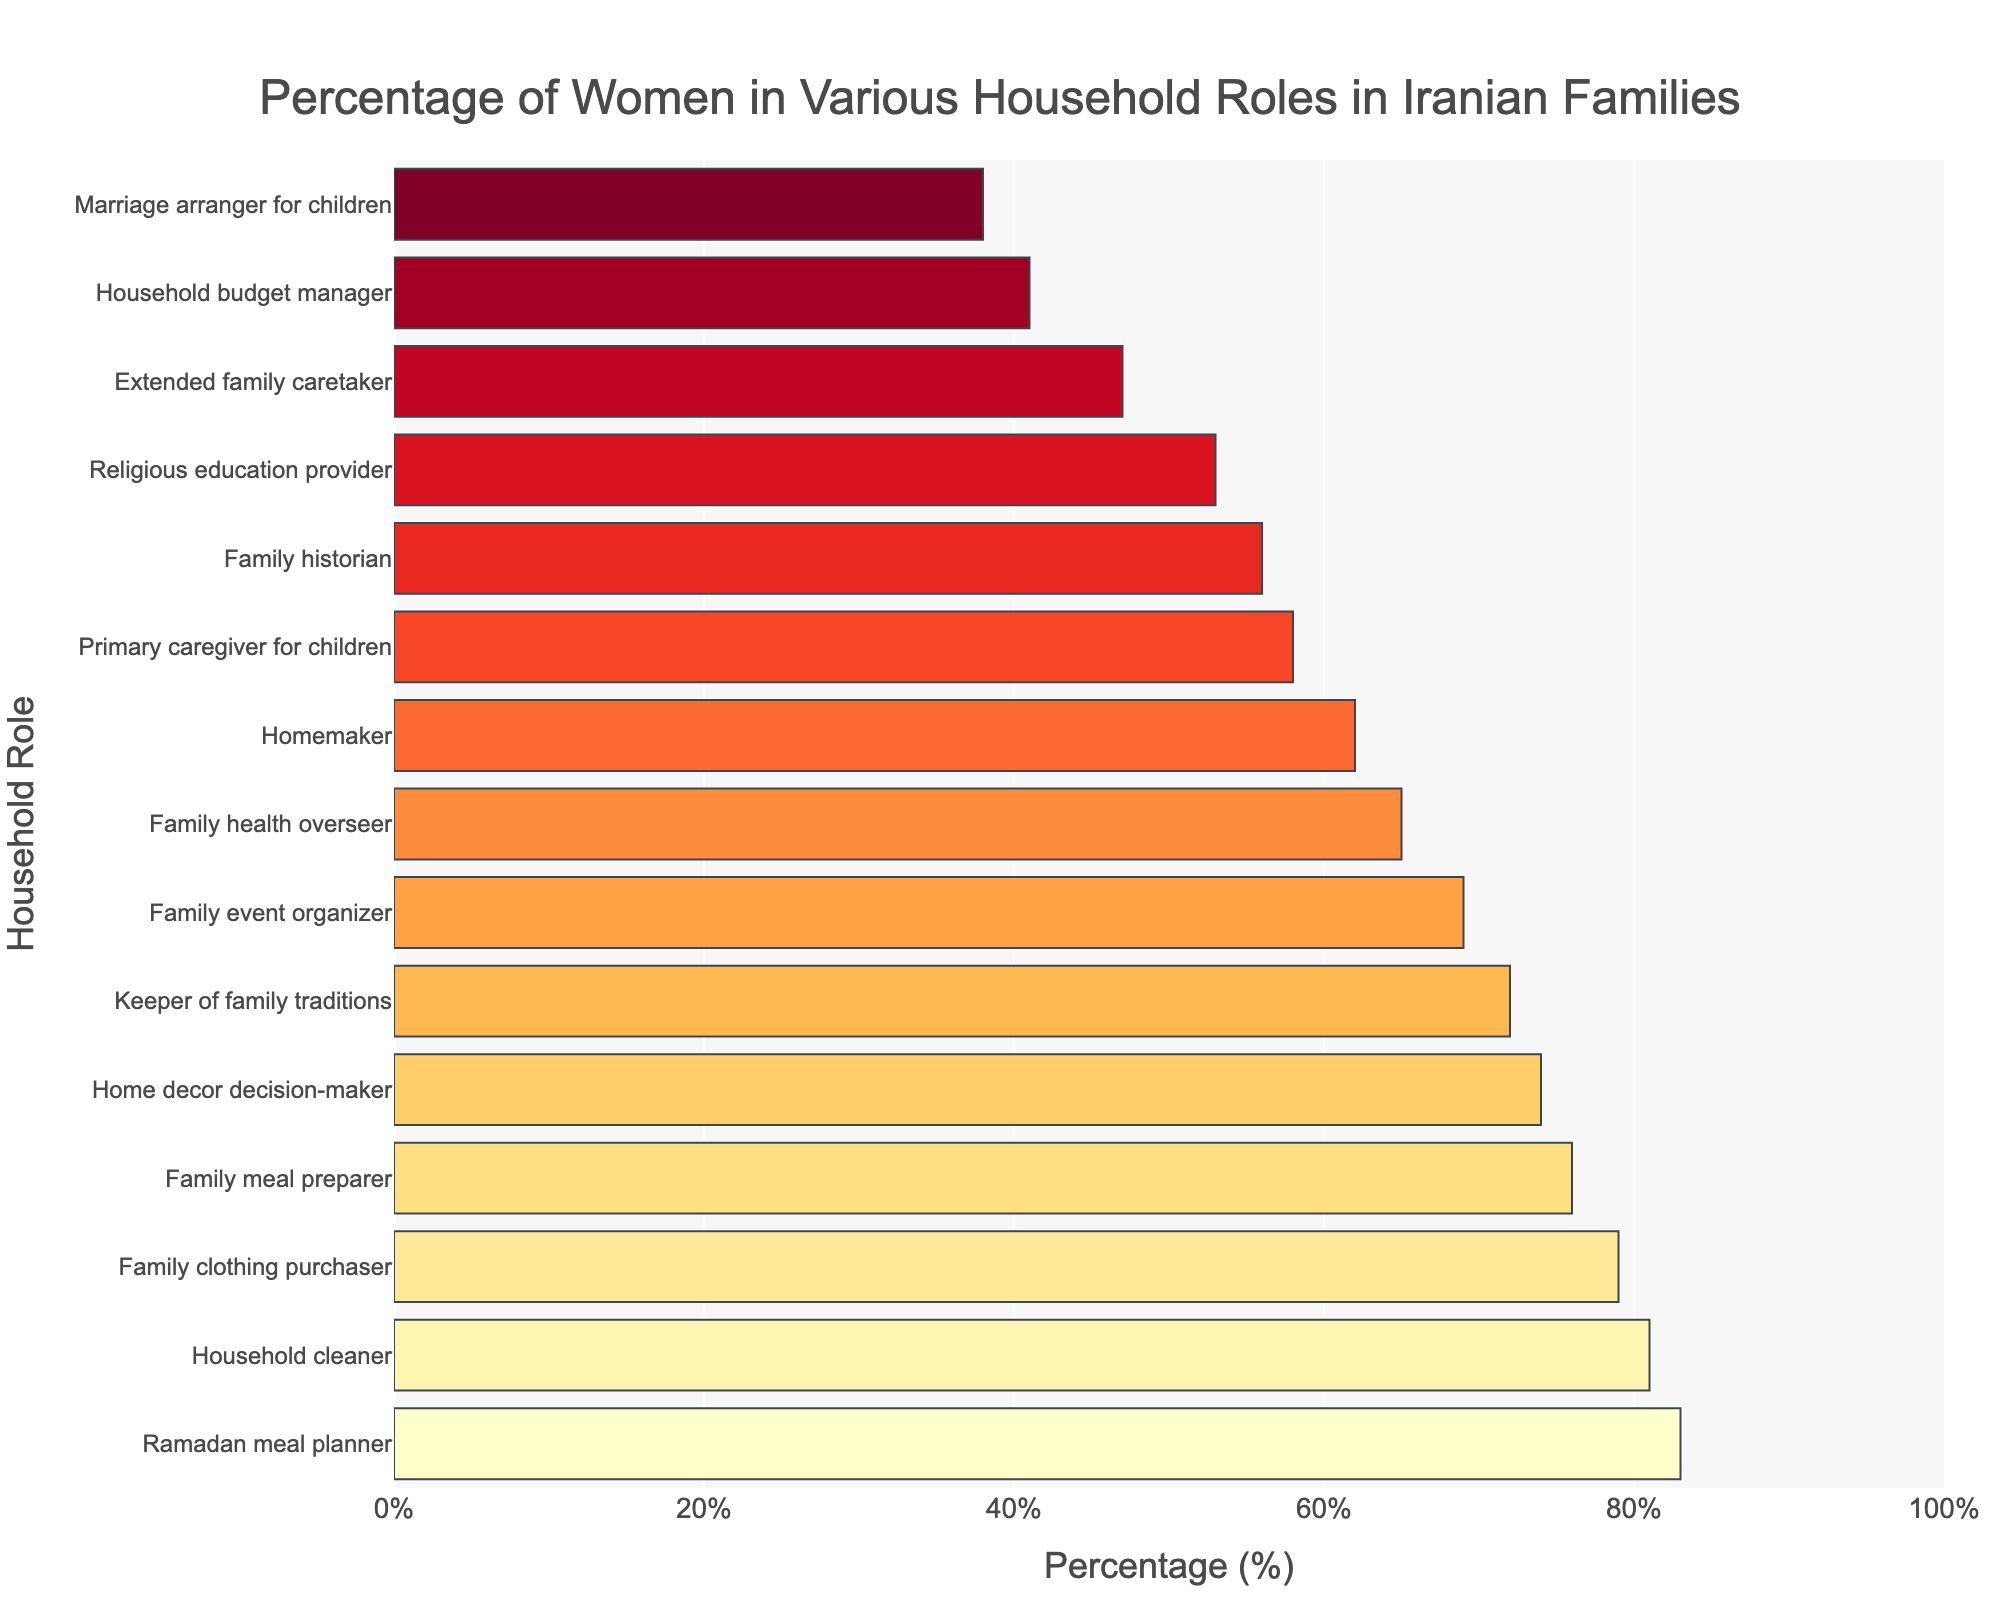What is the role with the highest percentage of women? The bar representing 'Ramadan meal planner' is the longest, indicating the highest percentage value of 83%.
Answer: Ramadan meal planner Which role has the smallest percentage of women? The shortest bar corresponds to 'Marriage arranger for children,' indicating it has the lowest percentage value of 38%.
Answer: Marriage arranger for children How much higher is the percentage of women as 'Household cleaner' than as 'Primary caregiver for children'? The percentage of women as 'Household cleaner' is 81% while as 'Primary caregiver for children' it is 58%. The difference is 81% - 58% = 23%.
Answer: 23% What is the average percentage of women in the roles of 'Household cleaner,' 'Keeper of family traditions,' and 'Family clothing purchaser'? The percentages are 81%, 72%, and 79% respectively. The average is calculated as (81 + 72 + 79) / 3 = 77.33%.
Answer: 77.33% Compare the percentage of women as 'Home decor decision-maker' with the percentage of women as 'Family event organizer'. Which is higher? The percentage of women as 'Home decor decision-maker' is 74%, while 'Family event organizer' is 69%. 74% > 69%, so 'Home decor decision-maker' is higher.
Answer: Home decor decision-maker How many roles have a percentage of women greater than 70%? By inspecting the bars, the roles 'Family meal preparer' (76%), 'Family event organizer' (69%), 'Keeper of family traditions' (72%), 'Household cleaner' (81%), 'Family clothing purchaser' (79%), 'Home decor decision-maker' (74%), and 'Ramadan meal planner' (83%) have percentages greater than 70%. This amounts to 7 roles.
Answer: 7 Is the percentage of women as 'Family historian' more or less than 60%? Observing the bar for 'Family historian,' its length indicates a percentage value of 56%, which is less than 60%.
Answer: Less than 60% What is the median percentage of women in the listed household roles? To find the median, we sort the percentages in descending order: 83, 81, 79, 76, 74, 72, 69, 65, 62, 58, 56, 53, 47, 41, 38. The median is the value in the middle position (8th value): 65%.
Answer: 65% Which roles have a percentage of women that is almost equal (within 1%)? The roles 'Primary caregiver for children' (58%) and 'Family historian' (56%) have percentages within 1% of each other.
Answer: Primary caregiver for children and Family historian 